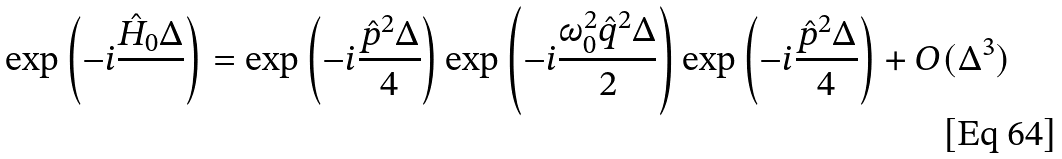<formula> <loc_0><loc_0><loc_500><loc_500>\exp { \left ( - i \frac { \hat { H } _ { 0 } \Delta } { } \right ) } = \exp { \left ( - i \frac { \hat { p } ^ { 2 } \Delta } { 4 } \right ) } \exp { \left ( - i \frac { \omega _ { 0 } ^ { 2 } \hat { q } ^ { 2 } \Delta } { 2 } \right ) } \exp { \left ( - i \frac { \hat { p } ^ { 2 } \Delta } { 4 } \right ) } + O ( \Delta ^ { 3 } )</formula> 